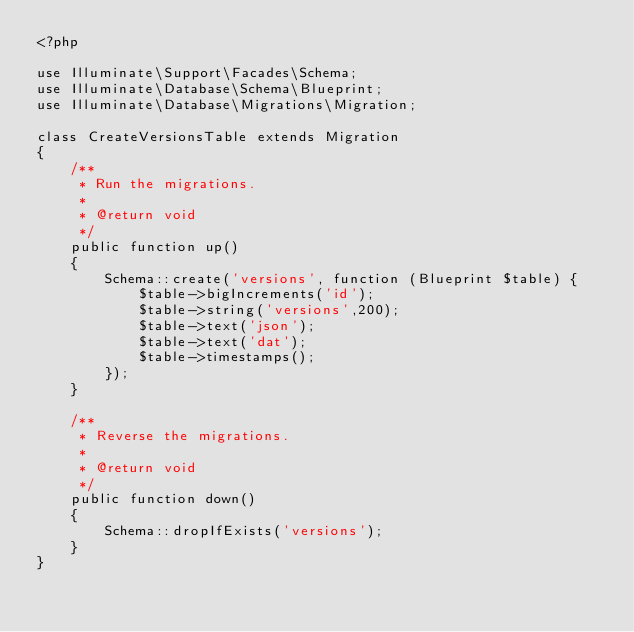<code> <loc_0><loc_0><loc_500><loc_500><_PHP_><?php

use Illuminate\Support\Facades\Schema;
use Illuminate\Database\Schema\Blueprint;
use Illuminate\Database\Migrations\Migration;

class CreateVersionsTable extends Migration
{
    /**
     * Run the migrations.
     *
     * @return void
     */
    public function up()
    {
        Schema::create('versions', function (Blueprint $table) {
            $table->bigIncrements('id');
            $table->string('versions',200);
            $table->text('json');
            $table->text('dat');
            $table->timestamps();
        });
    }

    /**
     * Reverse the migrations.
     *
     * @return void
     */
    public function down()
    {
        Schema::dropIfExists('versions');
    }
}
</code> 